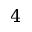Convert formula to latex. <formula><loc_0><loc_0><loc_500><loc_500>4</formula> 